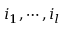Convert formula to latex. <formula><loc_0><loc_0><loc_500><loc_500>i _ { 1 } , \cdots , i _ { l }</formula> 